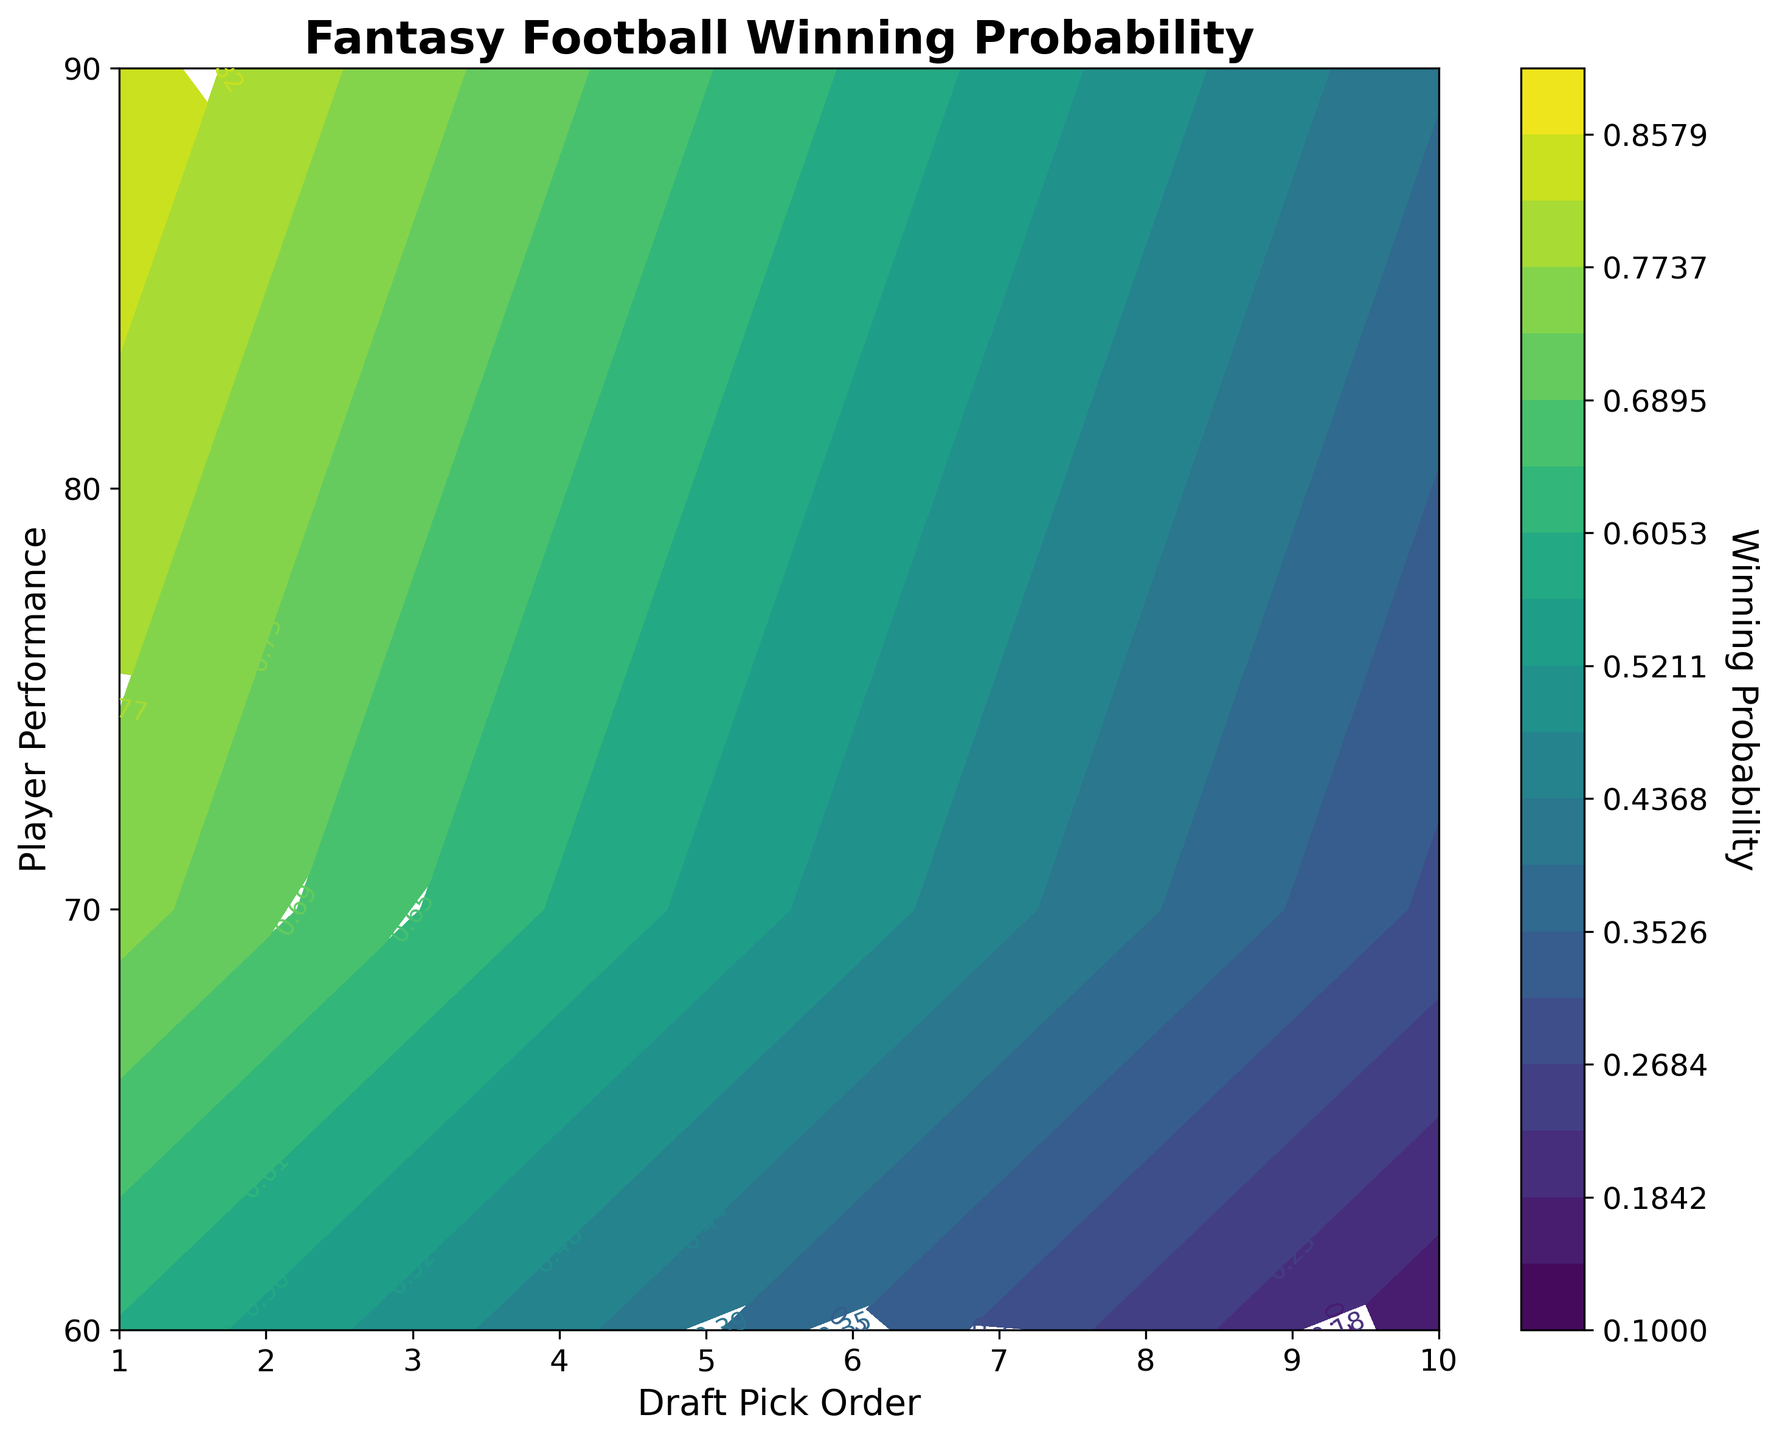What is the title of the plot? The title is located at the top of the plot and is displayed in bold and large font.
Answer: Fantasy Football Winning Probability What is the highest value on the colorbar? The colorbar ranges from 0.10 to 0.90, and the highest value is visible at the top of the color gradient.
Answer: 0.90 At which draft pick order do players with a performance score of 70 have a winning probability around 0.55? By locating the value '70' on the y-axis and '0.55' on the contour labels, the corresponding draft pick order can be identified on the x-axis.
Answer: 5 How does the winning probability change as the draft pick order increases from 1 to 10 for players with a performance score of 80? Observe the contour lines associated with a performance score of 80 and note the change in winning probability as you move from draft pick 1 to draft pick 10 on the x-axis. The probability visibly decreases.
Answer: It decreases What's the winning probability of a player with the highest performance score and the lowest draft pick order? The highest performance score is 90 and the lowest draft pick order is 1. Locate where these two values intersect on the plot to find the winning probability.
Answer: 0.85 Compare the winning probability for draft pick order 2 versus draft pick order 4 for players with a performance score of 90. Locate the values '2' and '4' on the x-axis and '90' on the y-axis, then compare the winning probabilities shown on the contour plot.
Answer: 0.80 (for draft pick 2) and 0.70 (for draft pick 4) If a player has a performance score of 60, what is their winning probability if they are the 7th draft pick? Find the intersection of '60' on the y-axis and '7' on the x-axis on the plot and observe the contour label at that point.
Answer: 0.30 What draft pick order provides the highest winning probability for a player with a performance score of 70? Look at the values along the x-axis for where the '70' on the y-axis intersects the highest contour label.
Answer: 1 